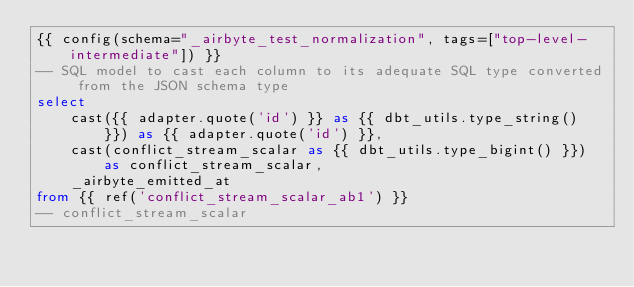Convert code to text. <code><loc_0><loc_0><loc_500><loc_500><_SQL_>{{ config(schema="_airbyte_test_normalization", tags=["top-level-intermediate"]) }}
-- SQL model to cast each column to its adequate SQL type converted from the JSON schema type
select
    cast({{ adapter.quote('id') }} as {{ dbt_utils.type_string() }}) as {{ adapter.quote('id') }},
    cast(conflict_stream_scalar as {{ dbt_utils.type_bigint() }}) as conflict_stream_scalar,
    _airbyte_emitted_at
from {{ ref('conflict_stream_scalar_ab1') }}
-- conflict_stream_scalar

</code> 